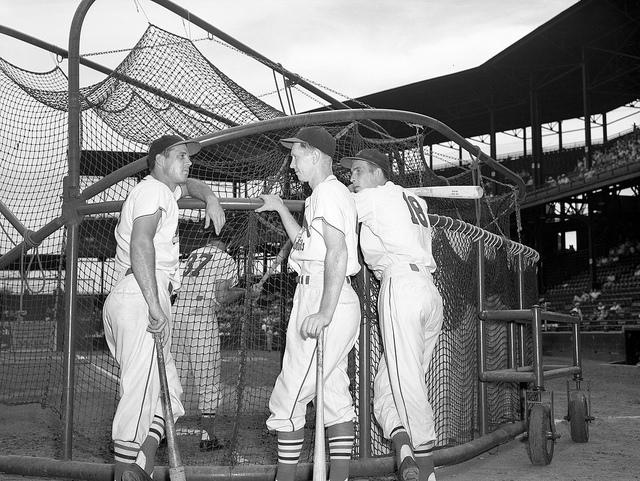How many bats are actually in use in the picture?
Keep it brief. 1. Are the players wearing St. Louis Cardinals uniforms?
Write a very short answer. Yes. Where on the field are the batters standing?
Quick response, please. Dugout. 